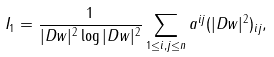Convert formula to latex. <formula><loc_0><loc_0><loc_500><loc_500>I _ { 1 } = \frac { 1 } { | D w | ^ { 2 } \log | D w | ^ { 2 } } \sum _ { 1 \leq i , j \leq n } a ^ { i j } ( | D w | ^ { 2 } ) _ { i j } ,</formula> 